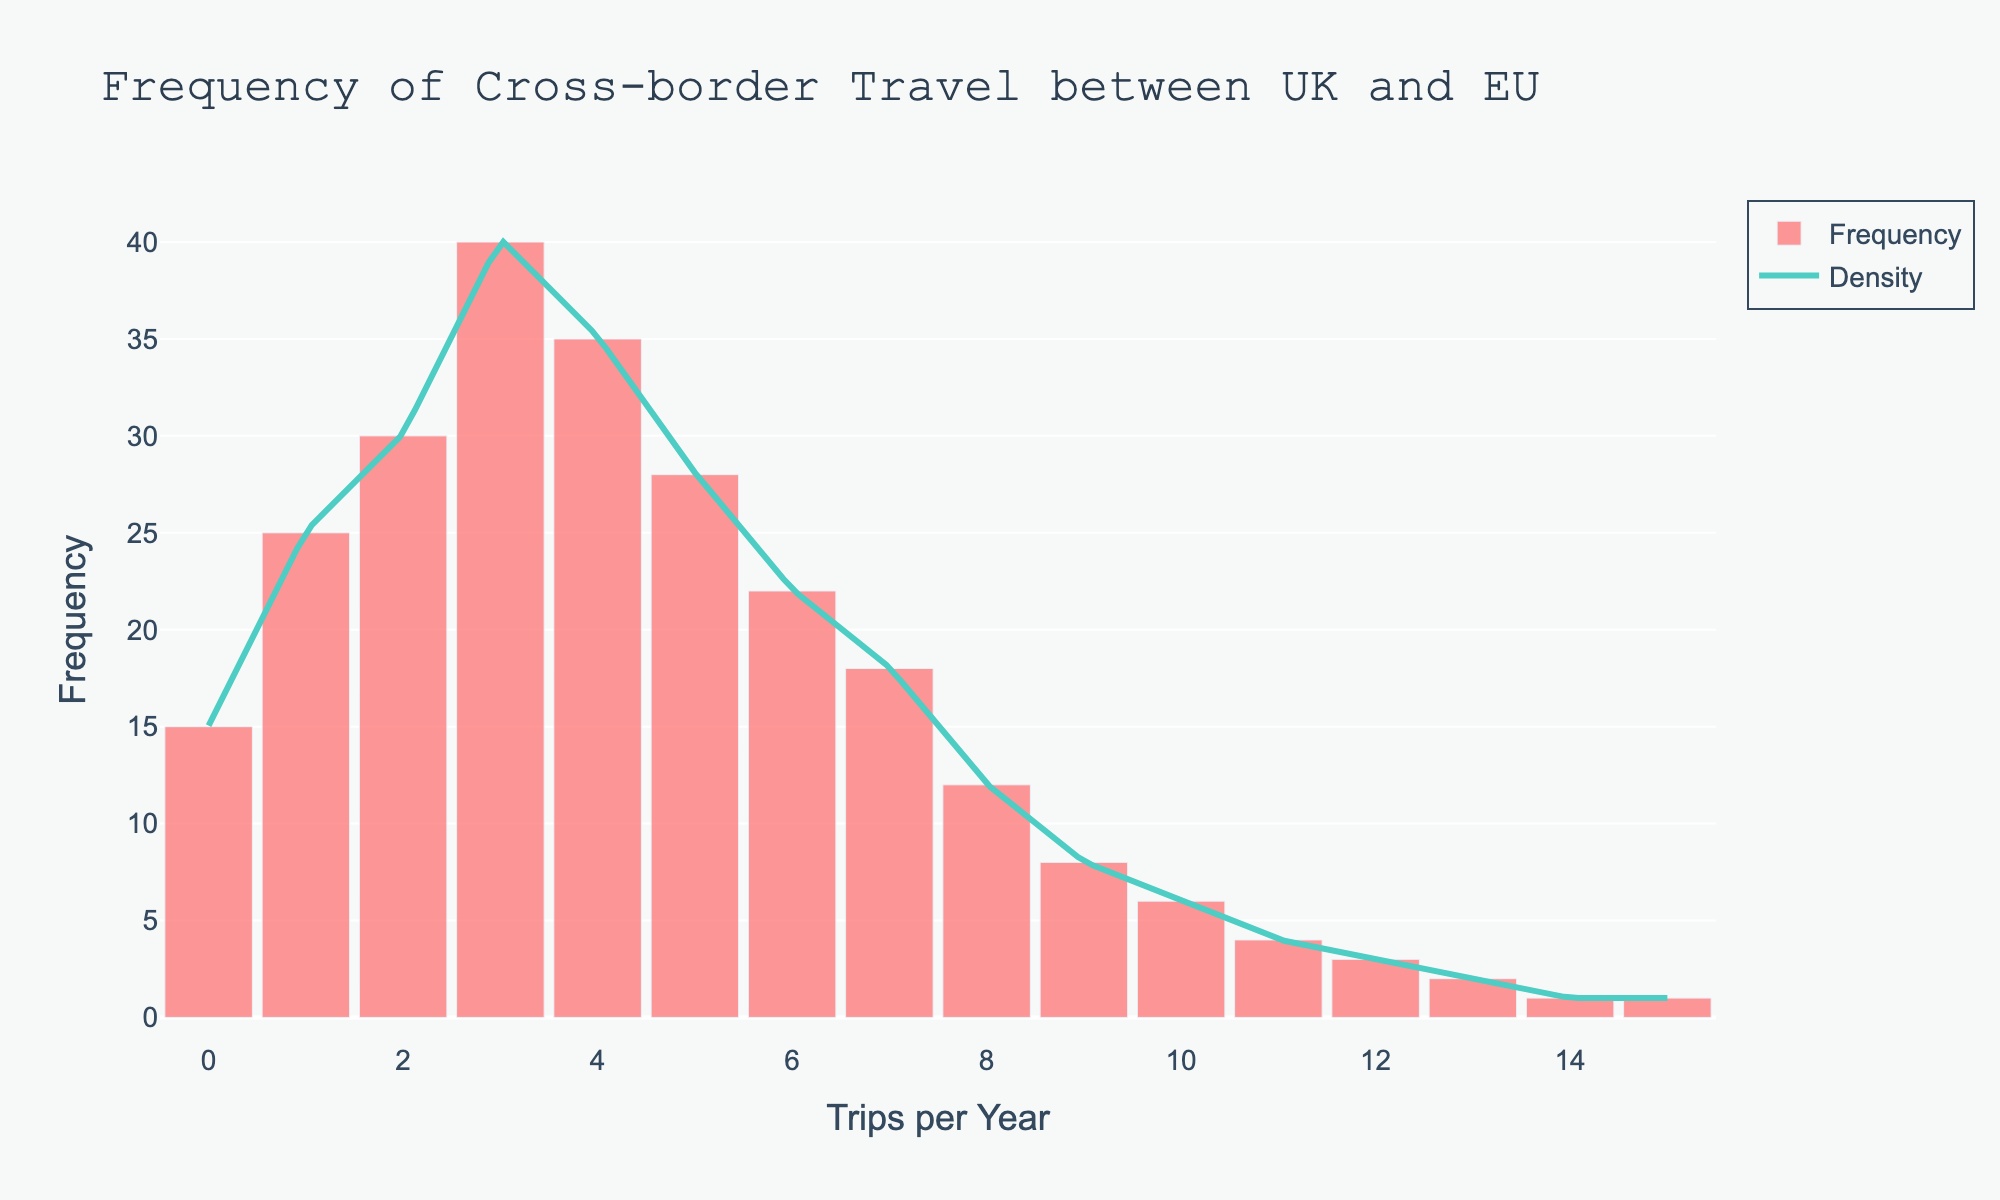What is the title of the figure? The title is displayed at the top of the chart and summarizes the main topic of the visualisation.
Answer: Frequency of Cross-border Travel between UK and EU How many trips per year have the highest frequency? By locating the bar with the greatest height, we can identify the number of trips per year with the highest frequency.
Answer: 3 What color represents the density curve in the figure? The density curve can be identified by its distinct color compared to the bars.
Answer: Green What is the frequency of people who made 4 trips per year? Find the bar corresponding to 4 trips per year and note its height.
Answer: 35 How do the frequencies of 1 trip per year compare to 7 trips per year? Locate the bars for 1 and 7 trips per year and compare their heights to determine which is greater.
Answer: 1 trip per year has a higher frequency (25 vs 18) Which number of trips per year has the lowest frequency? Identify the smallest bar in the histogram.
Answer: 14 and 15 both have the lowest frequency, which is 1 What is the sum of the frequencies of people who made 0 and 2 trips per year? Add the heights of the bars representing 0 and 2 trips per year.
Answer: 15 + 30 = 45 Are there more people who made 6 trips per year or 8 trips per year? Compare the heights of the bars for 6 and 8 trips per year.
Answer: 6 trips per year (22 vs 12) Which trips per year have a frequency exactly equal to 6? Locate the bars with a height corresponding to a frequency of 6.
Answer: 10 What does the shape of the KDE (density curve) suggest about the distribution of the frequency of trips per year? The shape of the KDE curve describes the smooth trend of the frequency distribution, showing peaks and valleys.
Answer: It suggests a high concentration of lower trip frequencies, peaking around 3 trips per year, and gradually decreasing as the number of trips increases 